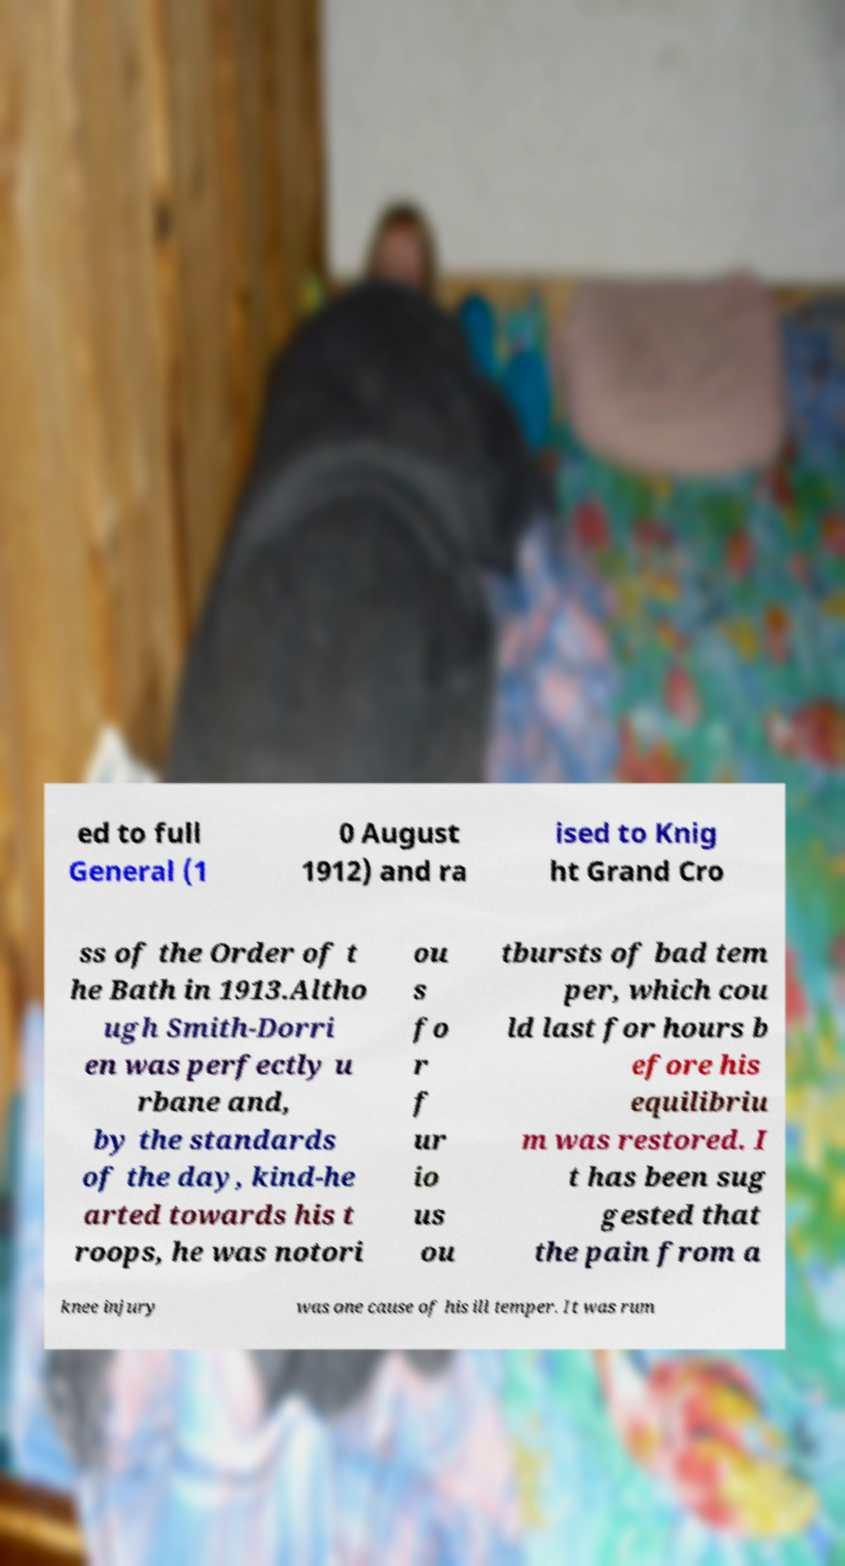For documentation purposes, I need the text within this image transcribed. Could you provide that? ed to full General (1 0 August 1912) and ra ised to Knig ht Grand Cro ss of the Order of t he Bath in 1913.Altho ugh Smith-Dorri en was perfectly u rbane and, by the standards of the day, kind-he arted towards his t roops, he was notori ou s fo r f ur io us ou tbursts of bad tem per, which cou ld last for hours b efore his equilibriu m was restored. I t has been sug gested that the pain from a knee injury was one cause of his ill temper. It was rum 